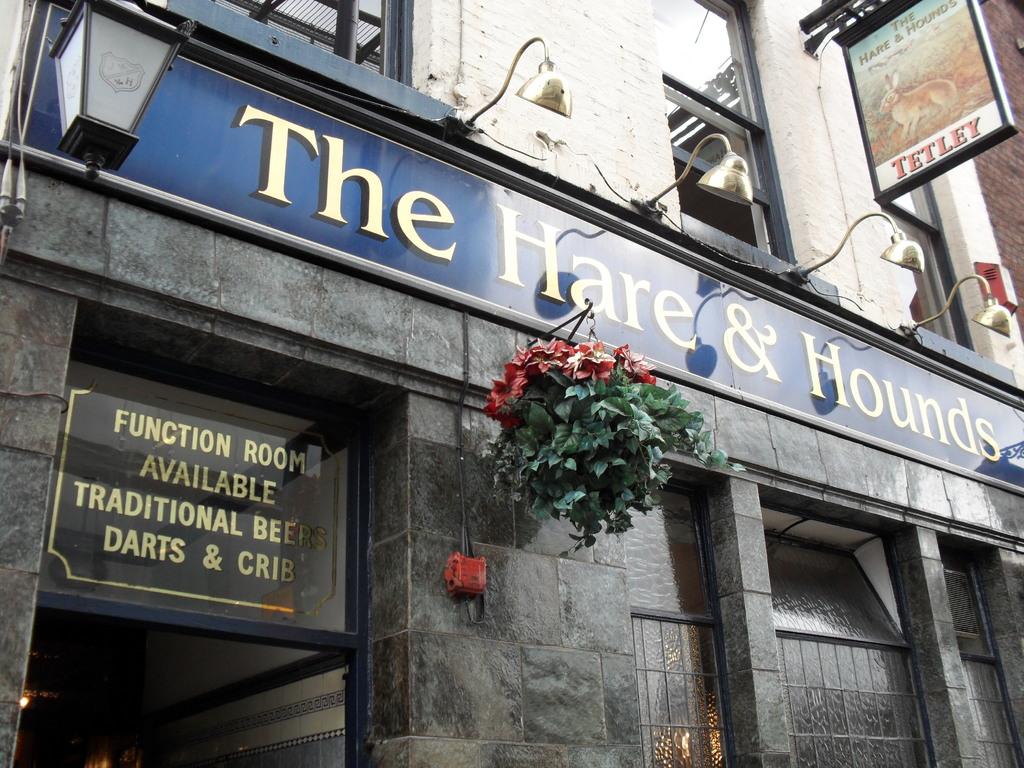What is the name of the place?
Provide a short and direct response. The hare & hounds. 